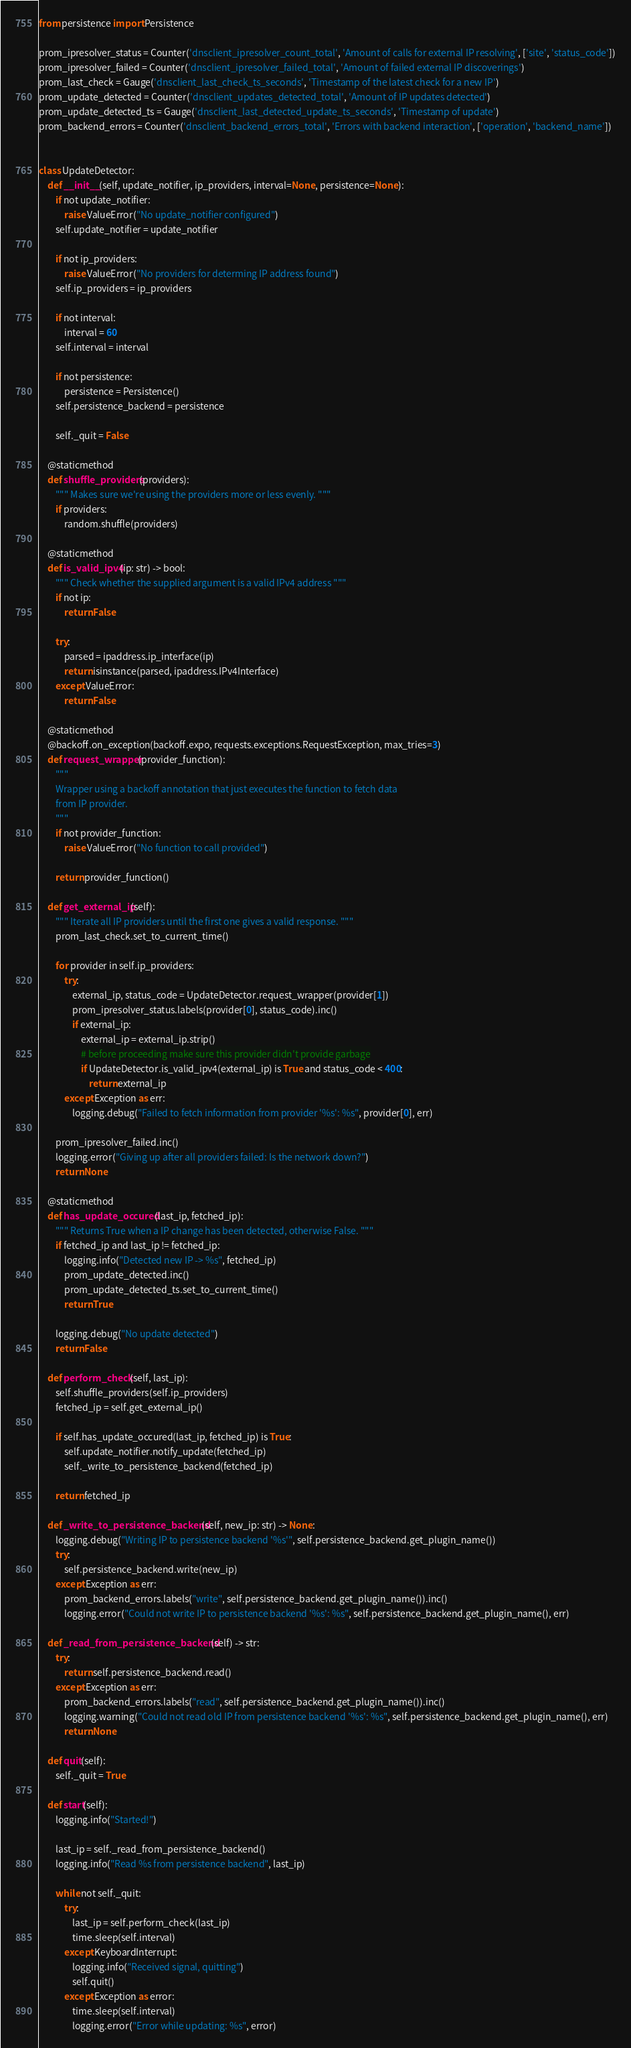Convert code to text. <code><loc_0><loc_0><loc_500><loc_500><_Python_>from persistence import Persistence

prom_ipresolver_status = Counter('dnsclient_ipresolver_count_total', 'Amount of calls for external IP resolving', ['site', 'status_code'])
prom_ipresolver_failed = Counter('dnsclient_ipresolver_failed_total', 'Amount of failed external IP discoverings')
prom_last_check = Gauge('dnsclient_last_check_ts_seconds', 'Timestamp of the latest check for a new IP')
prom_update_detected = Counter('dnsclient_updates_detected_total', 'Amount of IP updates detected')
prom_update_detected_ts = Gauge('dnsclient_last_detected_update_ts_seconds', 'Timestamp of update')
prom_backend_errors = Counter('dnsclient_backend_errors_total', 'Errors with backend interaction', ['operation', 'backend_name'])


class UpdateDetector:
    def __init__(self, update_notifier, ip_providers, interval=None, persistence=None):
        if not update_notifier:
            raise ValueError("No update_notifier configured")
        self.update_notifier = update_notifier

        if not ip_providers:
            raise ValueError("No providers for determing IP address found")
        self.ip_providers = ip_providers
        
        if not interval:
            interval = 60
        self.interval = interval

        if not persistence:
            persistence = Persistence()
        self.persistence_backend = persistence

        self._quit = False
    
    @staticmethod
    def shuffle_providers(providers):
        """ Makes sure we're using the providers more or less evenly. """
        if providers:
            random.shuffle(providers)

    @staticmethod
    def is_valid_ipv4(ip: str) -> bool:
        """ Check whether the supplied argument is a valid IPv4 address """
        if not ip:
            return False

        try:
            parsed = ipaddress.ip_interface(ip)
            return isinstance(parsed, ipaddress.IPv4Interface)
        except ValueError:
            return False

    @staticmethod
    @backoff.on_exception(backoff.expo, requests.exceptions.RequestException, max_tries=3)
    def request_wrapper(provider_function):
        """
        Wrapper using a backoff annotation that just executes the function to fetch data
        from IP provider.
        """
        if not provider_function:
            raise ValueError("No function to call provided")

        return provider_function()

    def get_external_ip(self):
        """ Iterate all IP providers until the first one gives a valid response. """
        prom_last_check.set_to_current_time()
        
        for provider in self.ip_providers:
            try:
                external_ip, status_code = UpdateDetector.request_wrapper(provider[1])
                prom_ipresolver_status.labels(provider[0], status_code).inc()
                if external_ip:
                    external_ip = external_ip.strip()
                    # before proceeding make sure this provider didn't provide garbage
                    if UpdateDetector.is_valid_ipv4(external_ip) is True and status_code < 400:
                        return external_ip
            except Exception as err:
                logging.debug("Failed to fetch information from provider '%s': %s", provider[0], err)

        prom_ipresolver_failed.inc()
        logging.error("Giving up after all providers failed: Is the network down?")
        return None

    @staticmethod
    def has_update_occured(last_ip, fetched_ip):
        """ Returns True when a IP change has been detected, otherwise False. """
        if fetched_ip and last_ip != fetched_ip:
            logging.info("Detected new IP -> %s", fetched_ip)
            prom_update_detected.inc()
            prom_update_detected_ts.set_to_current_time()
            return True

        logging.debug("No update detected")
        return False

    def perform_check(self, last_ip):
        self.shuffle_providers(self.ip_providers)
        fetched_ip = self.get_external_ip()

        if self.has_update_occured(last_ip, fetched_ip) is True:
            self.update_notifier.notify_update(fetched_ip)
            self._write_to_persistence_backend(fetched_ip)
            
        return fetched_ip

    def _write_to_persistence_backend(self, new_ip: str) -> None:
        logging.debug("Writing IP to persistence backend '%s'", self.persistence_backend.get_plugin_name())
        try:
            self.persistence_backend.write(new_ip)
        except Exception as err:
            prom_backend_errors.labels("write", self.persistence_backend.get_plugin_name()).inc()
            logging.error("Could not write IP to persistence backend '%s': %s", self.persistence_backend.get_plugin_name(), err)

    def _read_from_persistence_backend(self) -> str:
        try:
            return self.persistence_backend.read()
        except Exception as err:
            prom_backend_errors.labels("read", self.persistence_backend.get_plugin_name()).inc()
            logging.warning("Could not read old IP from persistence backend '%s': %s", self.persistence_backend.get_plugin_name(), err)
            return None

    def quit(self):
        self._quit = True

    def start(self):
        logging.info("Started!")

        last_ip = self._read_from_persistence_backend()
        logging.info("Read %s from persistence backend", last_ip)

        while not self._quit:
            try:
                last_ip = self.perform_check(last_ip)
                time.sleep(self.interval)
            except KeyboardInterrupt:
                logging.info("Received signal, quitting")
                self.quit()
            except Exception as error:
                time.sleep(self.interval)
                logging.error("Error while updating: %s", error)</code> 